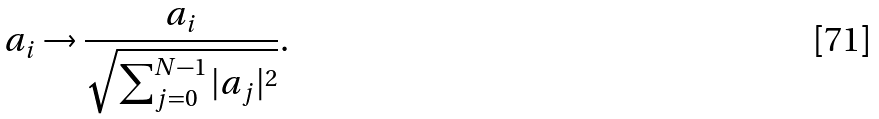<formula> <loc_0><loc_0><loc_500><loc_500>a _ { i } \rightarrow \frac { a _ { i } } { \sqrt { \sum _ { j = 0 } ^ { N - 1 } | a _ { j } | ^ { 2 } } } .</formula> 